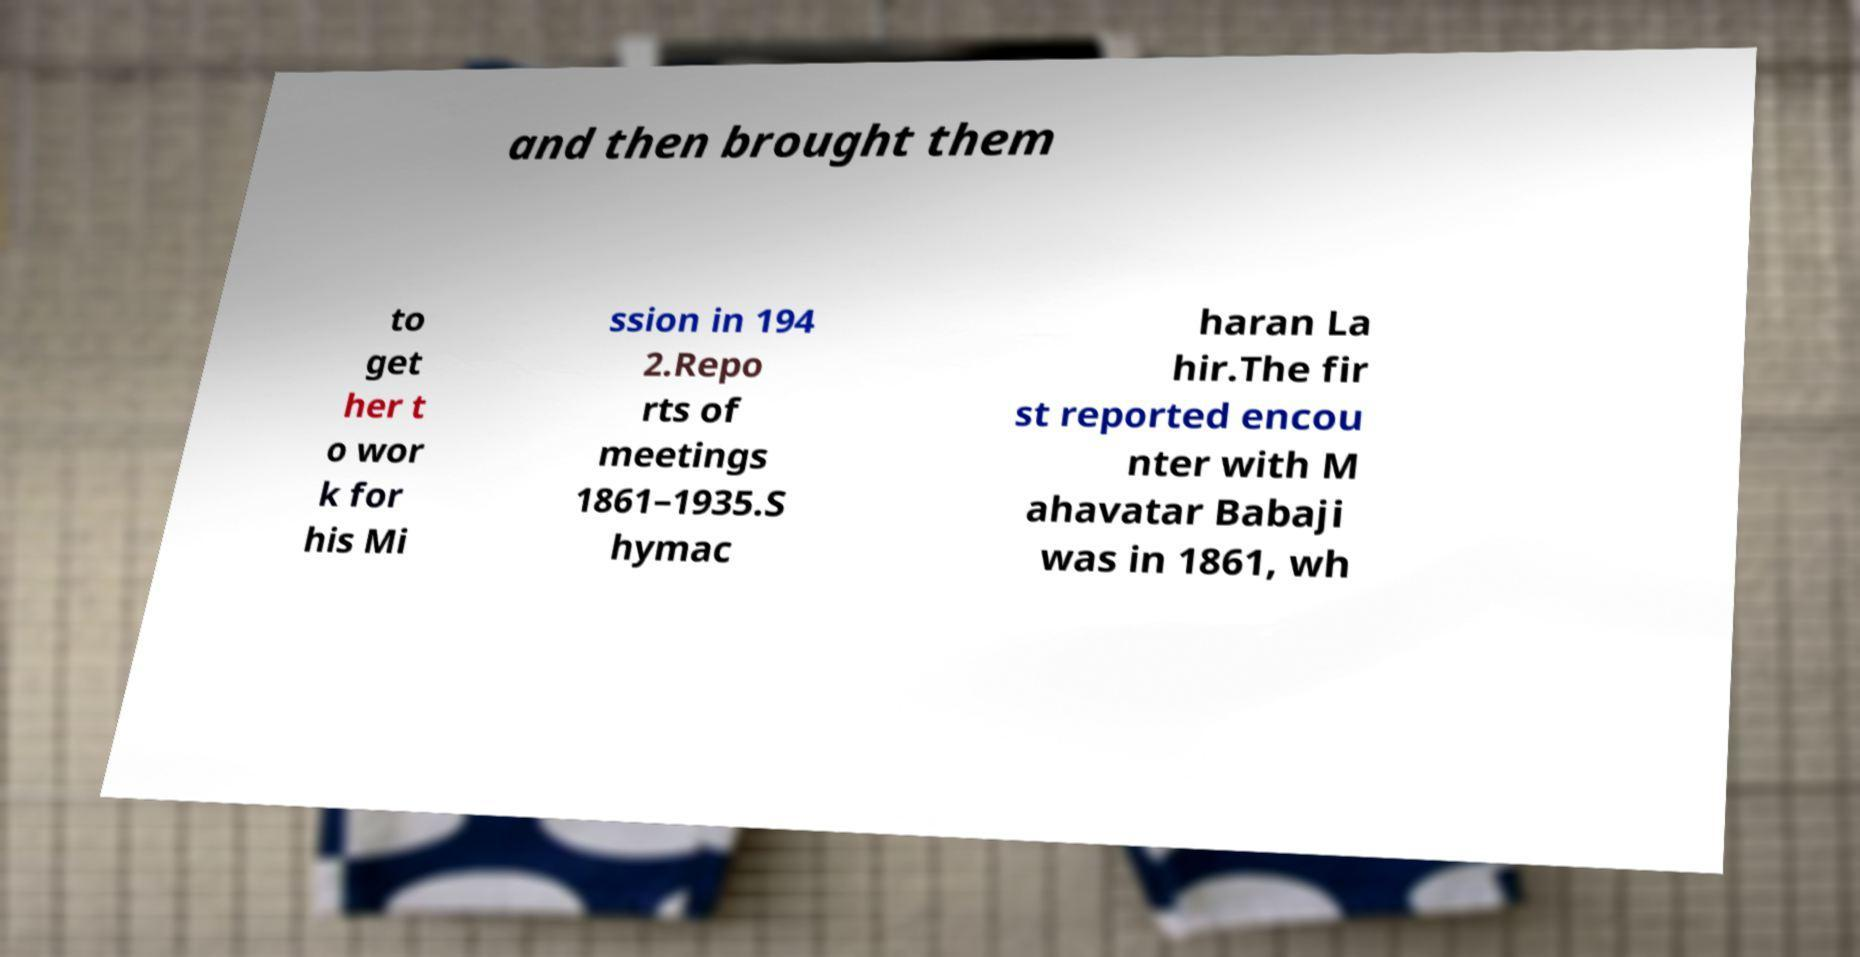Can you accurately transcribe the text from the provided image for me? and then brought them to get her t o wor k for his Mi ssion in 194 2.Repo rts of meetings 1861–1935.S hymac haran La hir.The fir st reported encou nter with M ahavatar Babaji was in 1861, wh 